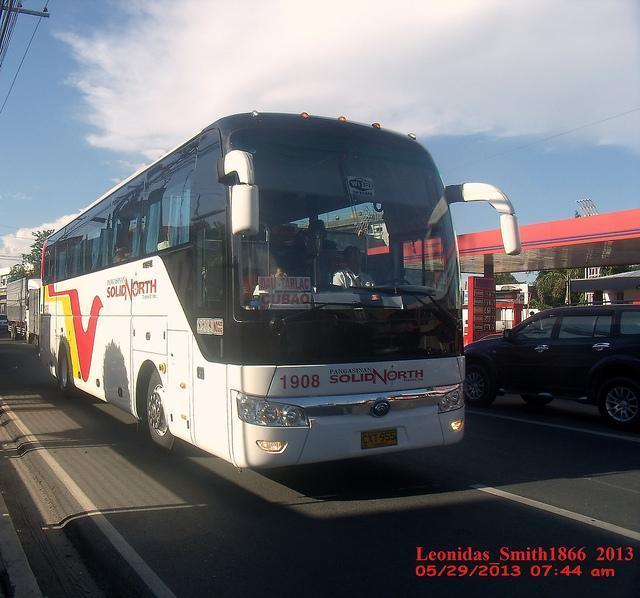How many cows are there?
Give a very brief answer. 0. 